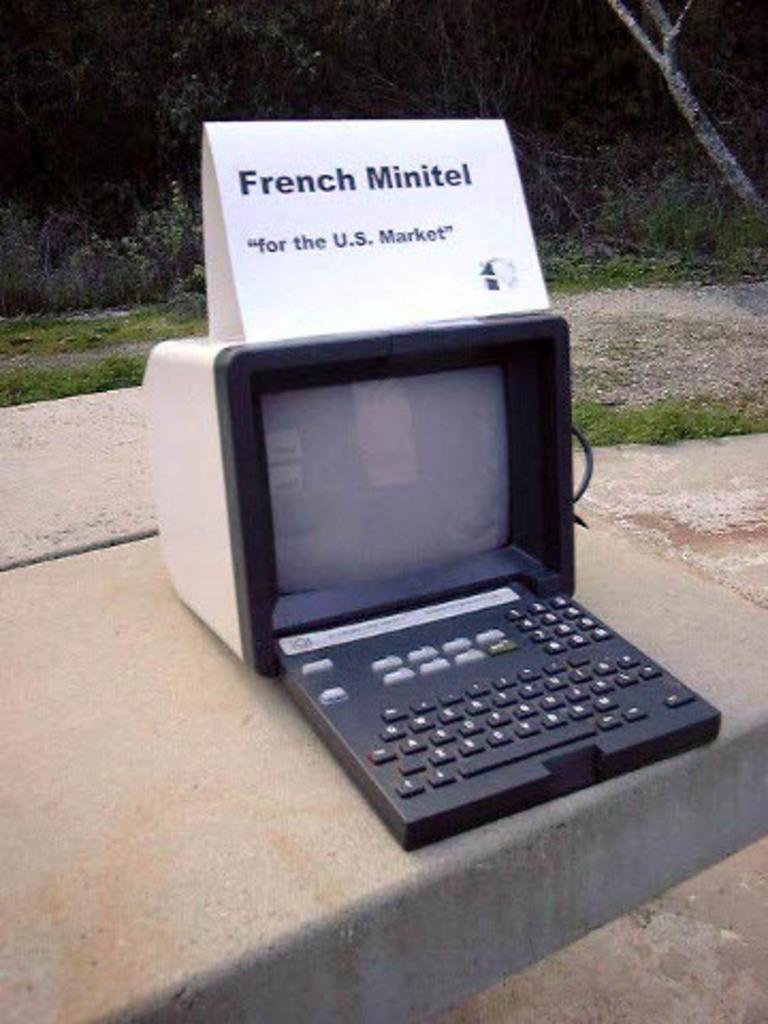Provide a one-sentence caption for the provided image. An old fashioned computer on a sidewalk with a sign that says French Minitel. 